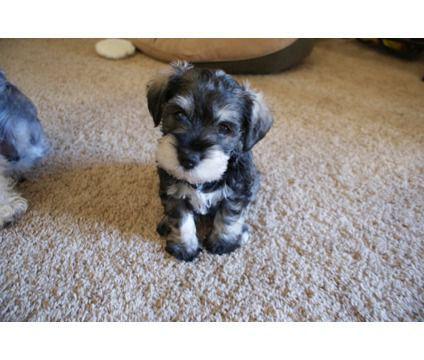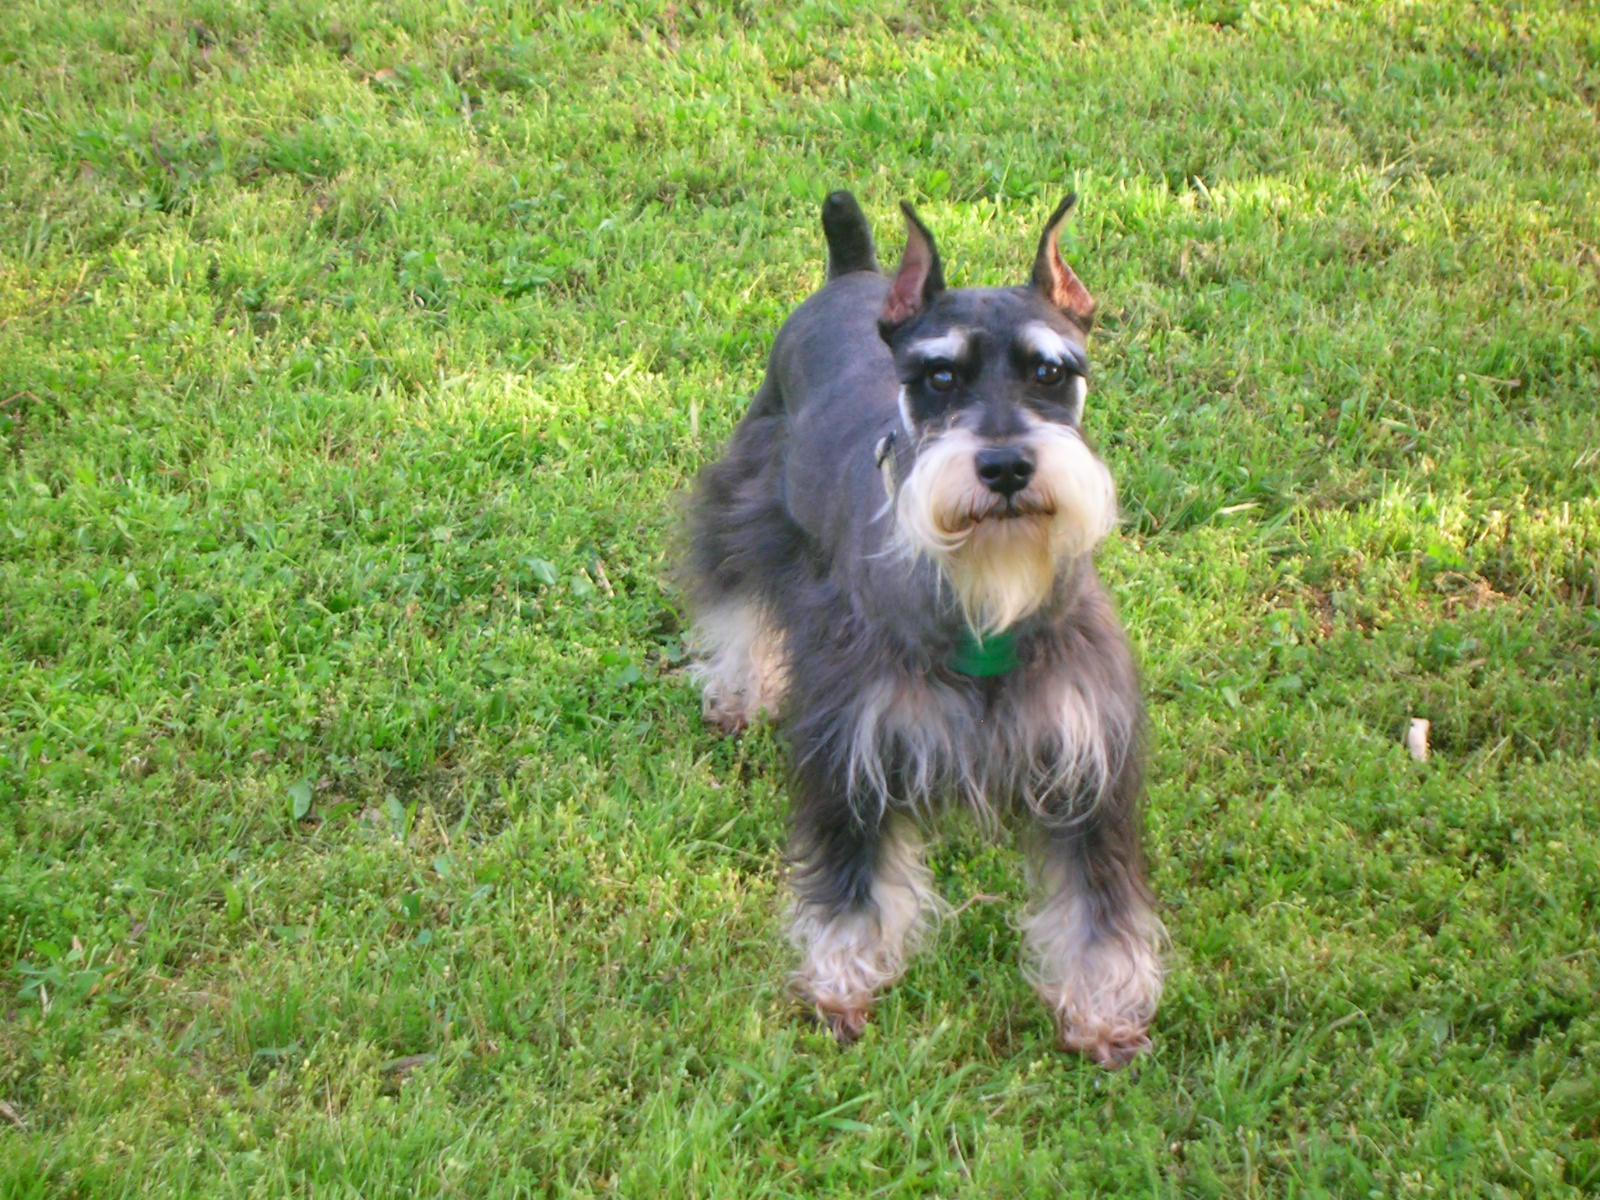The first image is the image on the left, the second image is the image on the right. Evaluate the accuracy of this statement regarding the images: "There are three dogs". Is it true? Answer yes or no. No. The first image is the image on the left, the second image is the image on the right. Given the left and right images, does the statement "Two schnauzers pose in the grass in one image." hold true? Answer yes or no. No. 